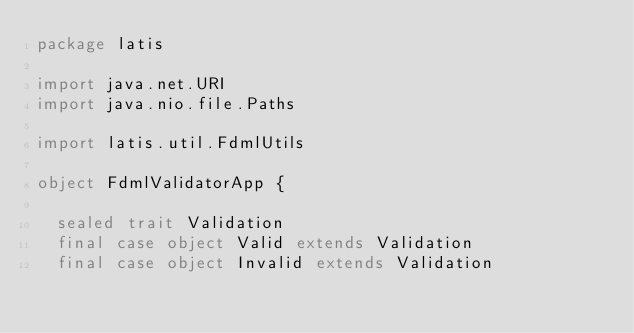<code> <loc_0><loc_0><loc_500><loc_500><_Scala_>package latis

import java.net.URI
import java.nio.file.Paths

import latis.util.FdmlUtils

object FdmlValidatorApp {

  sealed trait Validation
  final case object Valid extends Validation
  final case object Invalid extends Validation
</code> 